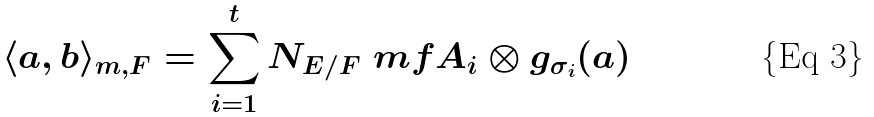Convert formula to latex. <formula><loc_0><loc_0><loc_500><loc_500>\langle a , b \rangle _ { m , F } = \sum _ { i = 1 } ^ { t } N _ { E / F } \ m f { A } _ { i } \otimes g _ { \sigma _ { i } } ( a )</formula> 